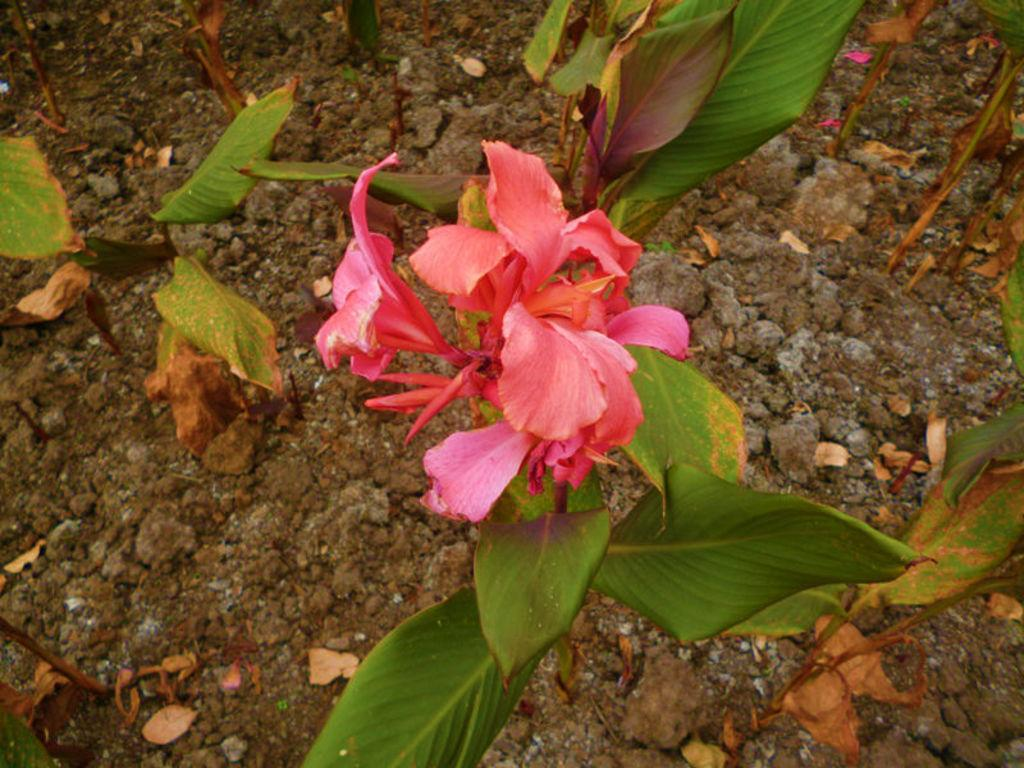What type of plants can be seen in the image? There are flowers in the image. What color are the flowers? The flowers are pink in color. What else can be seen in the image besides the flowers? There are leaves in the image. What color are the leaves? The leaves are green in color. What type of voice can be heard coming from the flowers in the image? There is no voice present in the image, as flowers do not have the ability to produce sound. 